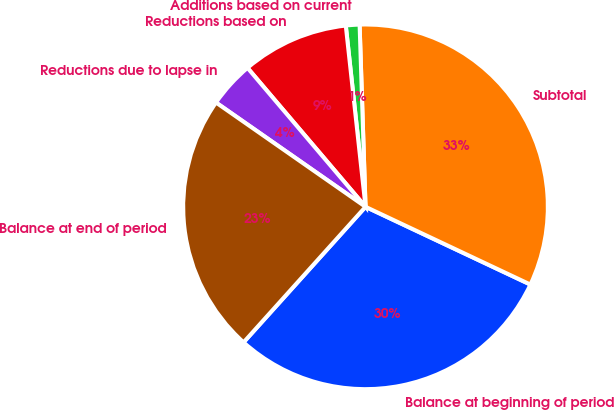Convert chart. <chart><loc_0><loc_0><loc_500><loc_500><pie_chart><fcel>Balance at beginning of period<fcel>Subtotal<fcel>Additions based on current<fcel>Reductions based on<fcel>Reductions due to lapse in<fcel>Balance at end of period<nl><fcel>29.65%<fcel>32.53%<fcel>1.21%<fcel>9.48%<fcel>4.1%<fcel>23.03%<nl></chart> 